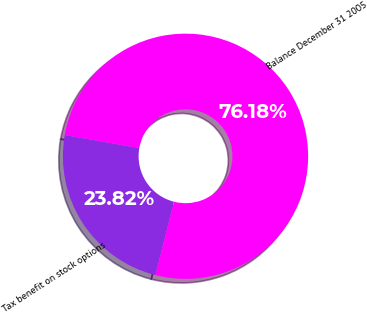<chart> <loc_0><loc_0><loc_500><loc_500><pie_chart><fcel>Tax benefit on stock options<fcel>Balance December 31 2005<nl><fcel>23.82%<fcel>76.18%<nl></chart> 